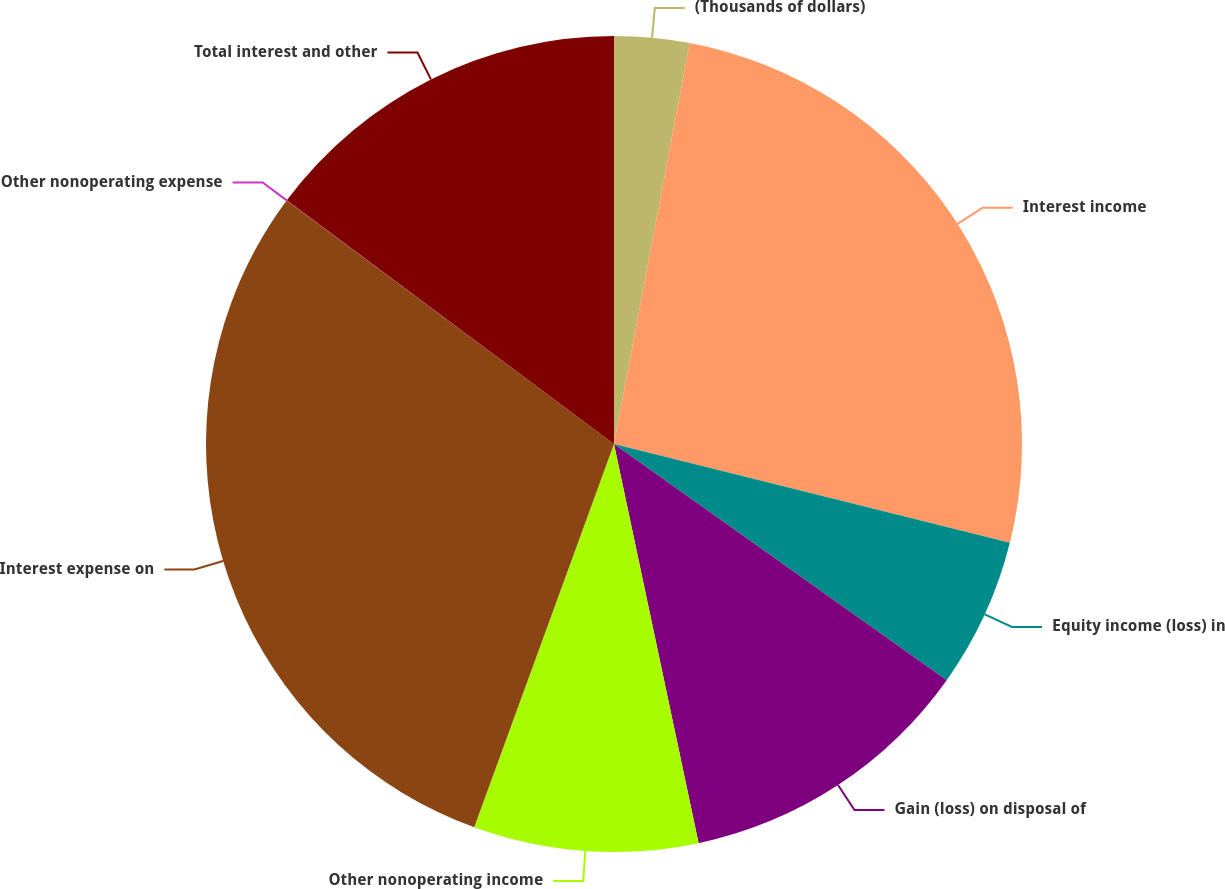<chart> <loc_0><loc_0><loc_500><loc_500><pie_chart><fcel>(Thousands of dollars)<fcel>Interest income<fcel>Equity income (loss) in<fcel>Gain (loss) on disposal of<fcel>Other nonoperating income<fcel>Interest expense on<fcel>Other nonoperating expense<fcel>Total interest and other<nl><fcel>2.97%<fcel>25.92%<fcel>5.93%<fcel>11.85%<fcel>8.89%<fcel>29.61%<fcel>0.01%<fcel>14.81%<nl></chart> 